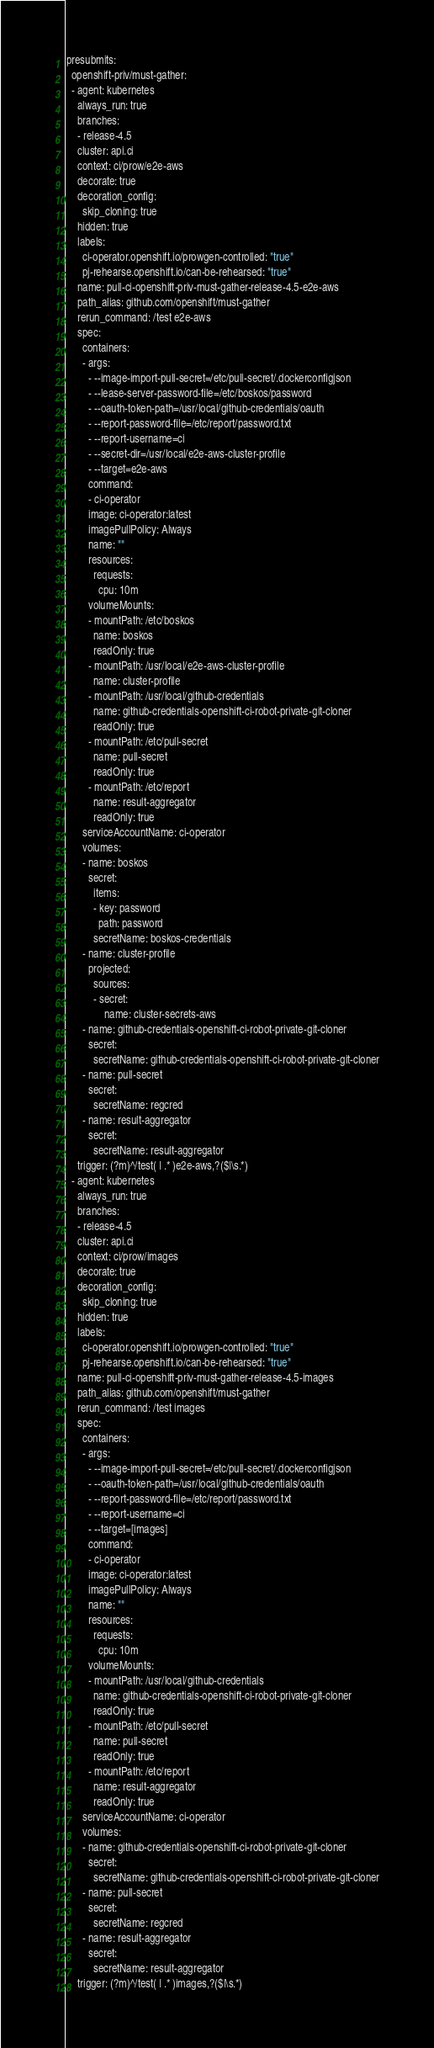Convert code to text. <code><loc_0><loc_0><loc_500><loc_500><_YAML_>presubmits:
  openshift-priv/must-gather:
  - agent: kubernetes
    always_run: true
    branches:
    - release-4.5
    cluster: api.ci
    context: ci/prow/e2e-aws
    decorate: true
    decoration_config:
      skip_cloning: true
    hidden: true
    labels:
      ci-operator.openshift.io/prowgen-controlled: "true"
      pj-rehearse.openshift.io/can-be-rehearsed: "true"
    name: pull-ci-openshift-priv-must-gather-release-4.5-e2e-aws
    path_alias: github.com/openshift/must-gather
    rerun_command: /test e2e-aws
    spec:
      containers:
      - args:
        - --image-import-pull-secret=/etc/pull-secret/.dockerconfigjson
        - --lease-server-password-file=/etc/boskos/password
        - --oauth-token-path=/usr/local/github-credentials/oauth
        - --report-password-file=/etc/report/password.txt
        - --report-username=ci
        - --secret-dir=/usr/local/e2e-aws-cluster-profile
        - --target=e2e-aws
        command:
        - ci-operator
        image: ci-operator:latest
        imagePullPolicy: Always
        name: ""
        resources:
          requests:
            cpu: 10m
        volumeMounts:
        - mountPath: /etc/boskos
          name: boskos
          readOnly: true
        - mountPath: /usr/local/e2e-aws-cluster-profile
          name: cluster-profile
        - mountPath: /usr/local/github-credentials
          name: github-credentials-openshift-ci-robot-private-git-cloner
          readOnly: true
        - mountPath: /etc/pull-secret
          name: pull-secret
          readOnly: true
        - mountPath: /etc/report
          name: result-aggregator
          readOnly: true
      serviceAccountName: ci-operator
      volumes:
      - name: boskos
        secret:
          items:
          - key: password
            path: password
          secretName: boskos-credentials
      - name: cluster-profile
        projected:
          sources:
          - secret:
              name: cluster-secrets-aws
      - name: github-credentials-openshift-ci-robot-private-git-cloner
        secret:
          secretName: github-credentials-openshift-ci-robot-private-git-cloner
      - name: pull-secret
        secret:
          secretName: regcred
      - name: result-aggregator
        secret:
          secretName: result-aggregator
    trigger: (?m)^/test( | .* )e2e-aws,?($|\s.*)
  - agent: kubernetes
    always_run: true
    branches:
    - release-4.5
    cluster: api.ci
    context: ci/prow/images
    decorate: true
    decoration_config:
      skip_cloning: true
    hidden: true
    labels:
      ci-operator.openshift.io/prowgen-controlled: "true"
      pj-rehearse.openshift.io/can-be-rehearsed: "true"
    name: pull-ci-openshift-priv-must-gather-release-4.5-images
    path_alias: github.com/openshift/must-gather
    rerun_command: /test images
    spec:
      containers:
      - args:
        - --image-import-pull-secret=/etc/pull-secret/.dockerconfigjson
        - --oauth-token-path=/usr/local/github-credentials/oauth
        - --report-password-file=/etc/report/password.txt
        - --report-username=ci
        - --target=[images]
        command:
        - ci-operator
        image: ci-operator:latest
        imagePullPolicy: Always
        name: ""
        resources:
          requests:
            cpu: 10m
        volumeMounts:
        - mountPath: /usr/local/github-credentials
          name: github-credentials-openshift-ci-robot-private-git-cloner
          readOnly: true
        - mountPath: /etc/pull-secret
          name: pull-secret
          readOnly: true
        - mountPath: /etc/report
          name: result-aggregator
          readOnly: true
      serviceAccountName: ci-operator
      volumes:
      - name: github-credentials-openshift-ci-robot-private-git-cloner
        secret:
          secretName: github-credentials-openshift-ci-robot-private-git-cloner
      - name: pull-secret
        secret:
          secretName: regcred
      - name: result-aggregator
        secret:
          secretName: result-aggregator
    trigger: (?m)^/test( | .* )images,?($|\s.*)
</code> 